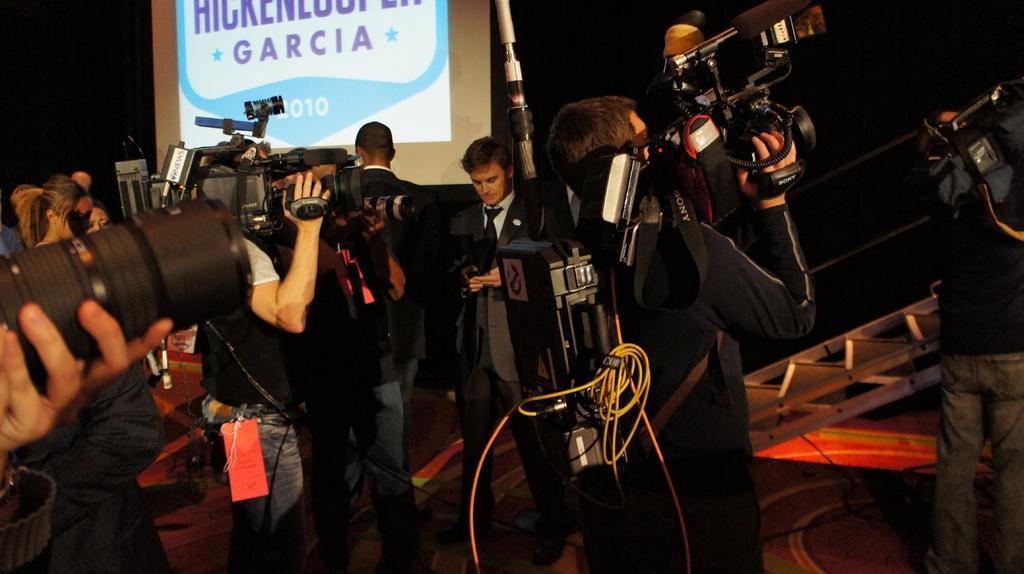Could you give a brief overview of what you see in this image? Here in this picture we can see a group of men standing over a place and all of them are carrying video cameras and cameras in their hands and apart from them we can see other men and women standing and we can also see a projector screen with something projected on it and on the left side we can see a ladder present. 